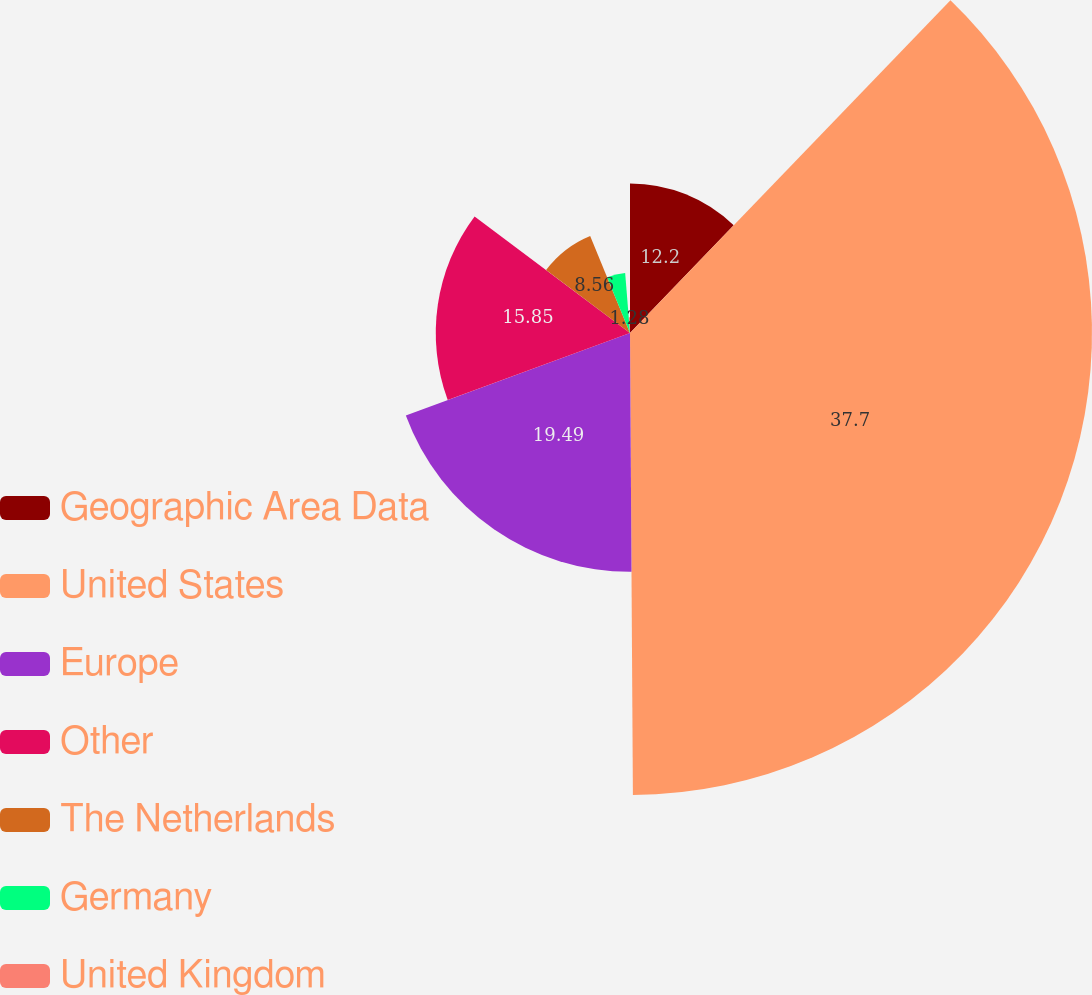Convert chart to OTSL. <chart><loc_0><loc_0><loc_500><loc_500><pie_chart><fcel>Geographic Area Data<fcel>United States<fcel>Europe<fcel>Other<fcel>The Netherlands<fcel>Germany<fcel>United Kingdom<nl><fcel>12.2%<fcel>37.7%<fcel>19.49%<fcel>15.85%<fcel>8.56%<fcel>4.92%<fcel>1.28%<nl></chart> 